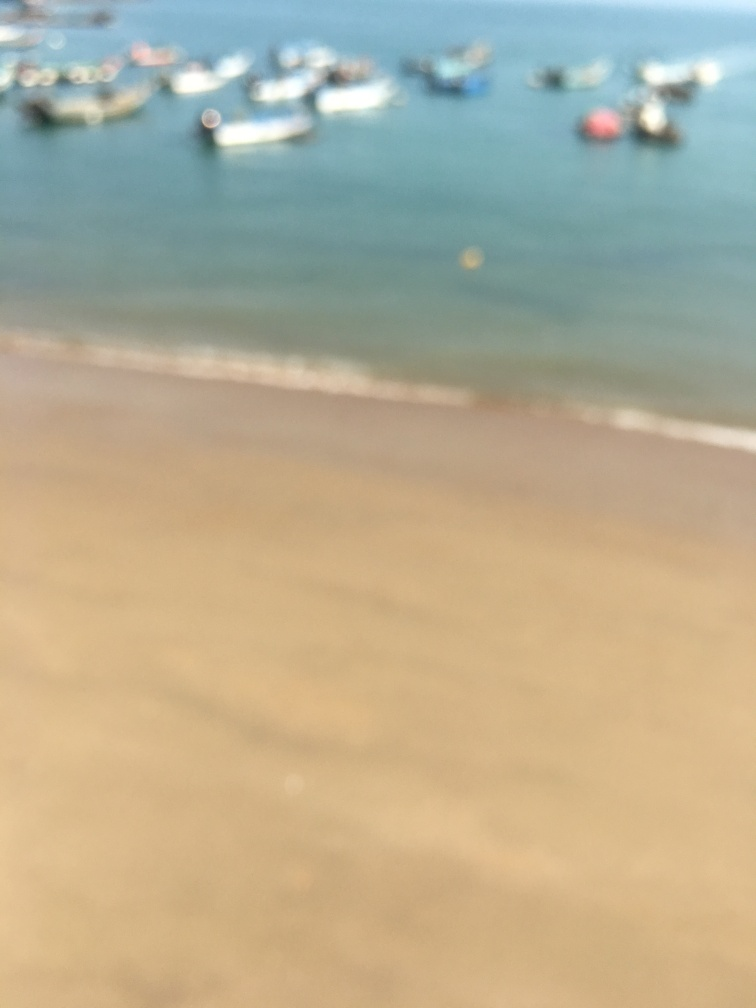What can be observed about the overall focus of this image? A. Sharp B. Crisp C. Blurry D. Clear Answer with the option's letter from the given choices directly. The overall focus of this image is blurry, as details are not sharp and the shapes lack clarity. This results in a dreamy or mysterious atmosphere and may have been a stylistic choice or a result of camera movement during exposure. 